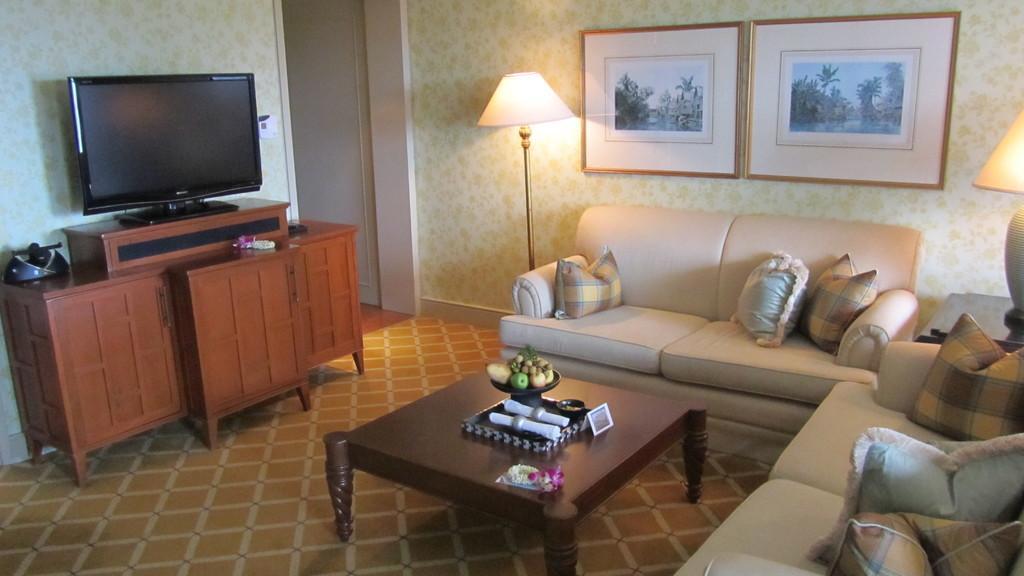Please provide a concise description of this image. This is the picture of a room where we have a sofa and some pillows on the sofa and a table in front of them on which there are some fruits and some things places and in front of them there is desk on which there is a TV and two frames and two lamps to the left side. 